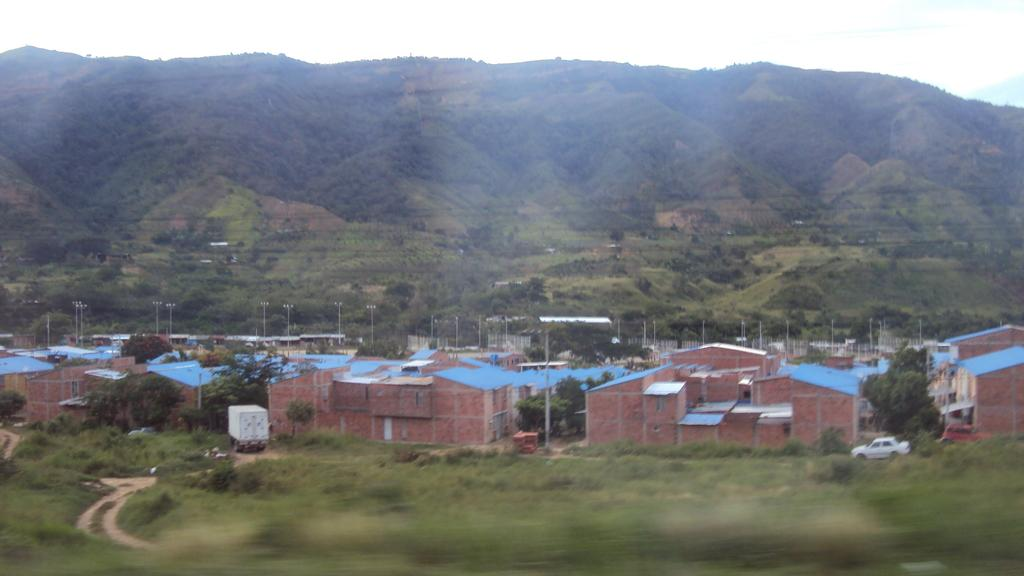What type of structures can be seen in the image? There are houses in the image. What else is visible besides the houses? Vehicles, poles, trees, mountains, and the sky are visible in the image. Can you describe the landscape in the image? The image features a landscape with trees, mountains, and the sky in the background. What might be used for transportation in the image? Vehicles are present in the image, which might be used for transportation. What is the reason for the credit score being so low in the image? There is no mention of credit scores or any financial information in the image. 